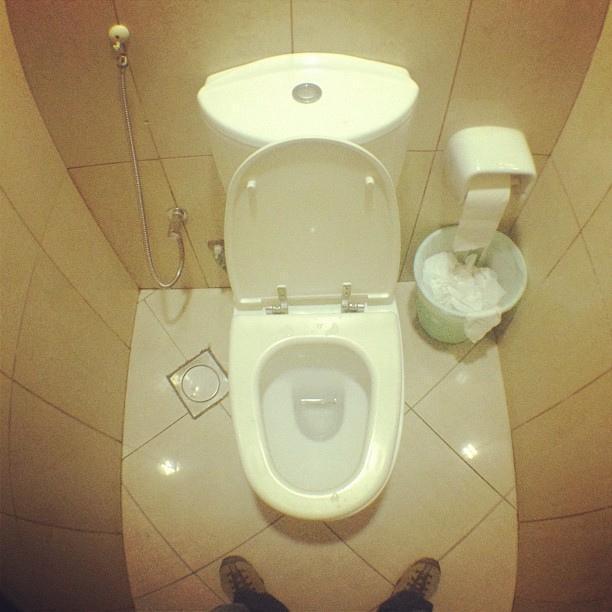How many times is the train number visible?
Give a very brief answer. 0. 